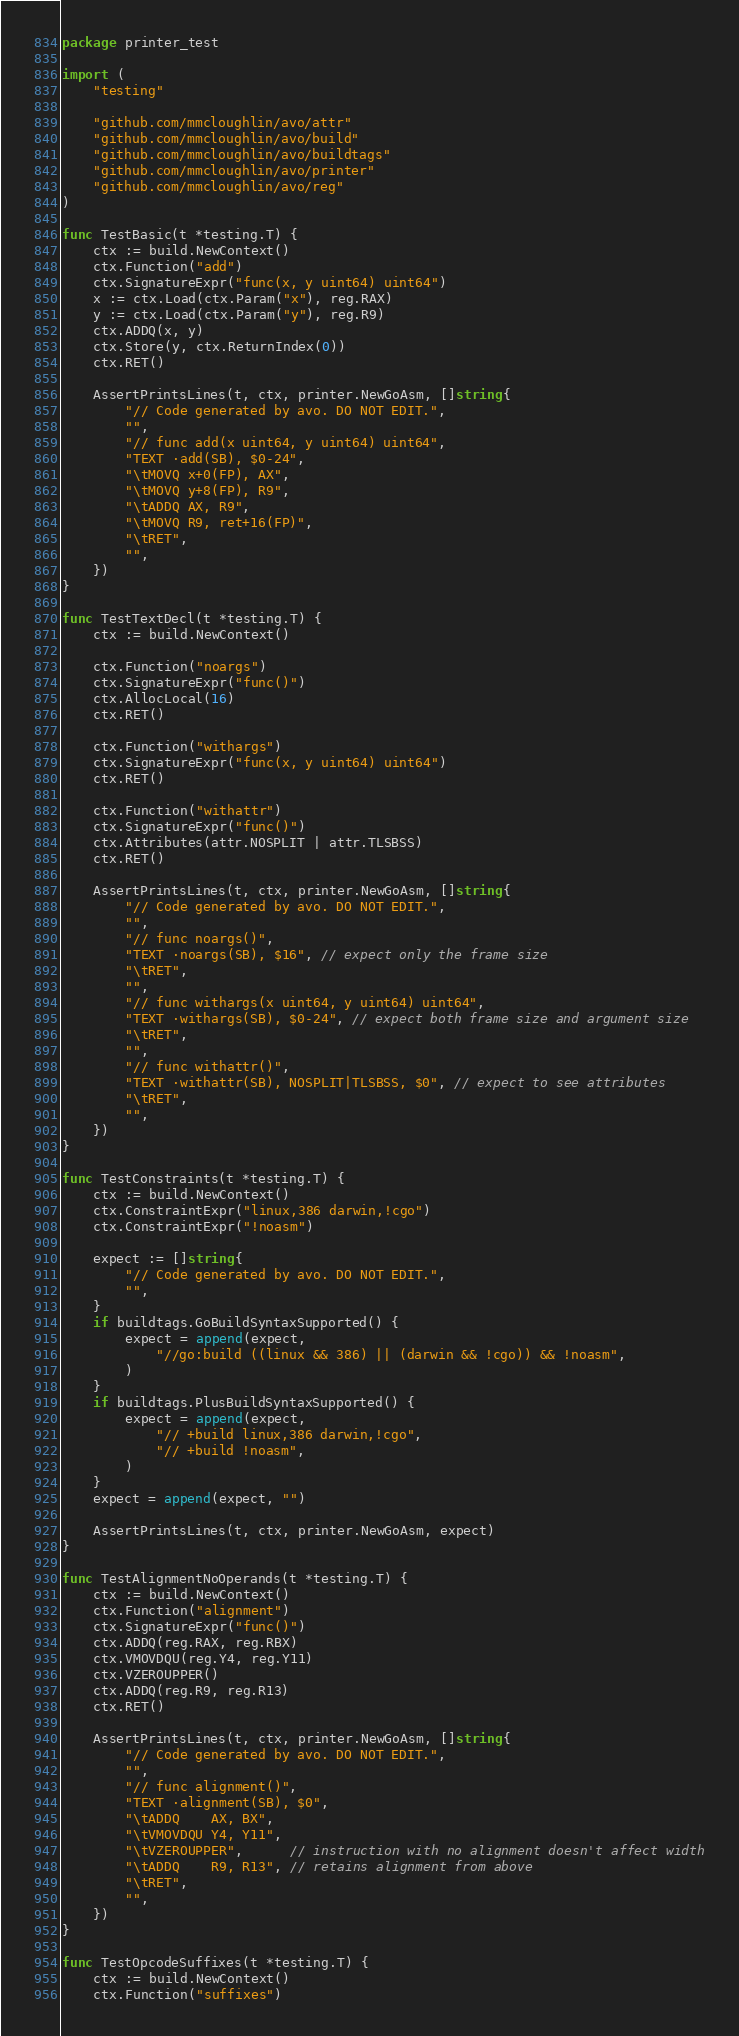Convert code to text. <code><loc_0><loc_0><loc_500><loc_500><_Go_>package printer_test

import (
	"testing"

	"github.com/mmcloughlin/avo/attr"
	"github.com/mmcloughlin/avo/build"
	"github.com/mmcloughlin/avo/buildtags"
	"github.com/mmcloughlin/avo/printer"
	"github.com/mmcloughlin/avo/reg"
)

func TestBasic(t *testing.T) {
	ctx := build.NewContext()
	ctx.Function("add")
	ctx.SignatureExpr("func(x, y uint64) uint64")
	x := ctx.Load(ctx.Param("x"), reg.RAX)
	y := ctx.Load(ctx.Param("y"), reg.R9)
	ctx.ADDQ(x, y)
	ctx.Store(y, ctx.ReturnIndex(0))
	ctx.RET()

	AssertPrintsLines(t, ctx, printer.NewGoAsm, []string{
		"// Code generated by avo. DO NOT EDIT.",
		"",
		"// func add(x uint64, y uint64) uint64",
		"TEXT ·add(SB), $0-24",
		"\tMOVQ x+0(FP), AX",
		"\tMOVQ y+8(FP), R9",
		"\tADDQ AX, R9",
		"\tMOVQ R9, ret+16(FP)",
		"\tRET",
		"",
	})
}

func TestTextDecl(t *testing.T) {
	ctx := build.NewContext()

	ctx.Function("noargs")
	ctx.SignatureExpr("func()")
	ctx.AllocLocal(16)
	ctx.RET()

	ctx.Function("withargs")
	ctx.SignatureExpr("func(x, y uint64) uint64")
	ctx.RET()

	ctx.Function("withattr")
	ctx.SignatureExpr("func()")
	ctx.Attributes(attr.NOSPLIT | attr.TLSBSS)
	ctx.RET()

	AssertPrintsLines(t, ctx, printer.NewGoAsm, []string{
		"// Code generated by avo. DO NOT EDIT.",
		"",
		"// func noargs()",
		"TEXT ·noargs(SB), $16", // expect only the frame size
		"\tRET",
		"",
		"// func withargs(x uint64, y uint64) uint64",
		"TEXT ·withargs(SB), $0-24", // expect both frame size and argument size
		"\tRET",
		"",
		"// func withattr()",
		"TEXT ·withattr(SB), NOSPLIT|TLSBSS, $0", // expect to see attributes
		"\tRET",
		"",
	})
}

func TestConstraints(t *testing.T) {
	ctx := build.NewContext()
	ctx.ConstraintExpr("linux,386 darwin,!cgo")
	ctx.ConstraintExpr("!noasm")

	expect := []string{
		"// Code generated by avo. DO NOT EDIT.",
		"",
	}
	if buildtags.GoBuildSyntaxSupported() {
		expect = append(expect,
			"//go:build ((linux && 386) || (darwin && !cgo)) && !noasm",
		)
	}
	if buildtags.PlusBuildSyntaxSupported() {
		expect = append(expect,
			"// +build linux,386 darwin,!cgo",
			"// +build !noasm",
		)
	}
	expect = append(expect, "")

	AssertPrintsLines(t, ctx, printer.NewGoAsm, expect)
}

func TestAlignmentNoOperands(t *testing.T) {
	ctx := build.NewContext()
	ctx.Function("alignment")
	ctx.SignatureExpr("func()")
	ctx.ADDQ(reg.RAX, reg.RBX)
	ctx.VMOVDQU(reg.Y4, reg.Y11)
	ctx.VZEROUPPER()
	ctx.ADDQ(reg.R9, reg.R13)
	ctx.RET()

	AssertPrintsLines(t, ctx, printer.NewGoAsm, []string{
		"// Code generated by avo. DO NOT EDIT.",
		"",
		"// func alignment()",
		"TEXT ·alignment(SB), $0",
		"\tADDQ    AX, BX",
		"\tVMOVDQU Y4, Y11",
		"\tVZEROUPPER",      // instruction with no alignment doesn't affect width
		"\tADDQ    R9, R13", // retains alignment from above
		"\tRET",
		"",
	})
}

func TestOpcodeSuffixes(t *testing.T) {
	ctx := build.NewContext()
	ctx.Function("suffixes")</code> 